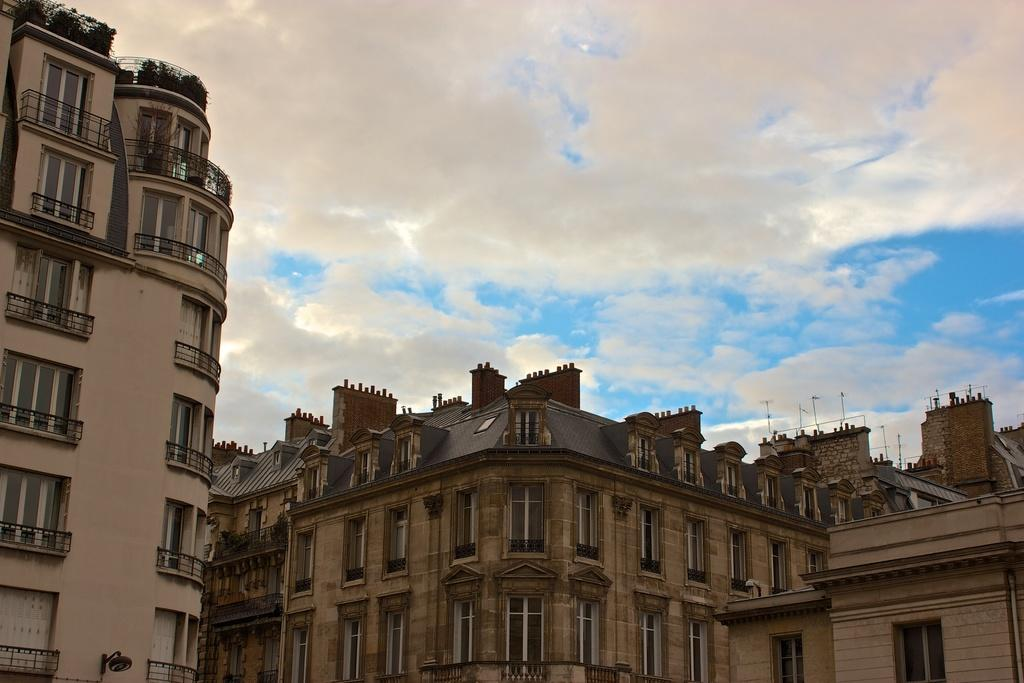What color are the buildings in the image? The buildings in the image are brown-colored. What features can be seen on the buildings? The buildings have windows and railings. What can be seen in the sky in the image? There are clouds visible in the image, and the sky is blue. What type of songs can be heard coming from the buildings in the image? There is no indication in the image that any songs are being played or heard from the buildings. 